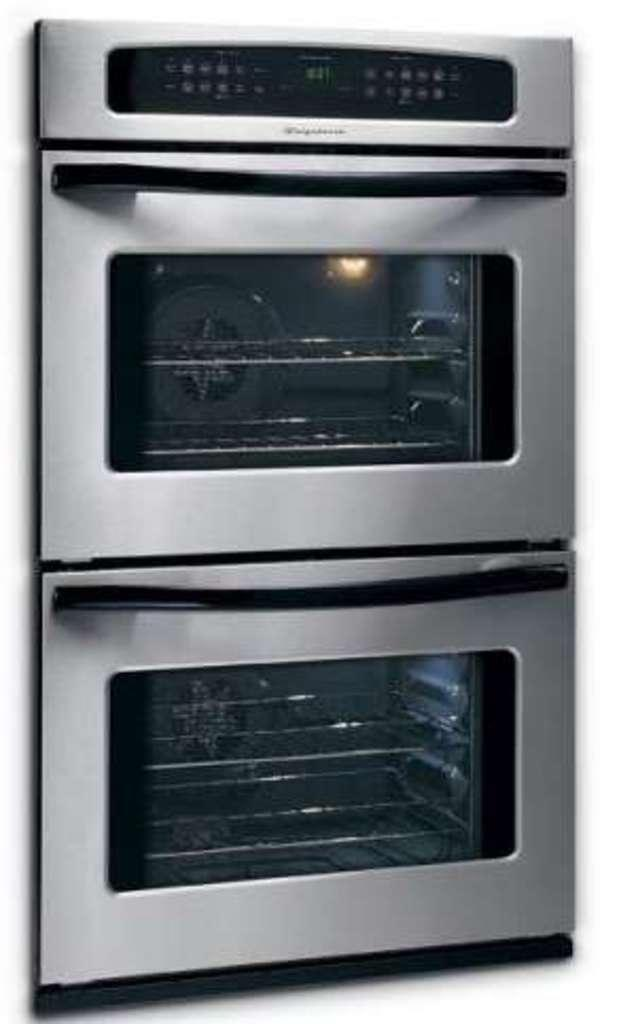How many microwave ovens are visible in the image? There are two microwave ovens in the image. What features are present above the microwave ovens? There are buttons and a digital display board above the microwave ovens. What can be found inside the microwave ovens? There are grills inside the ovens. What type of juice is being printed on the fact sheet in the image? There is no juice or fact sheet present in the image; it only features microwave ovens with buttons, a digital display board, and grills inside. 